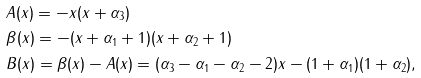Convert formula to latex. <formula><loc_0><loc_0><loc_500><loc_500>& A ( x ) = - x ( x + \alpha _ { 3 } ) \\ & \beta ( x ) = - ( x + \alpha _ { 1 } + 1 ) ( x + \alpha _ { 2 } + 1 ) \\ & B ( x ) = \beta ( x ) - A ( x ) = ( \alpha _ { 3 } - \alpha _ { 1 } - \alpha _ { 2 } - 2 ) x - ( 1 + \alpha _ { 1 } ) ( 1 + \alpha _ { 2 } ) ,</formula> 